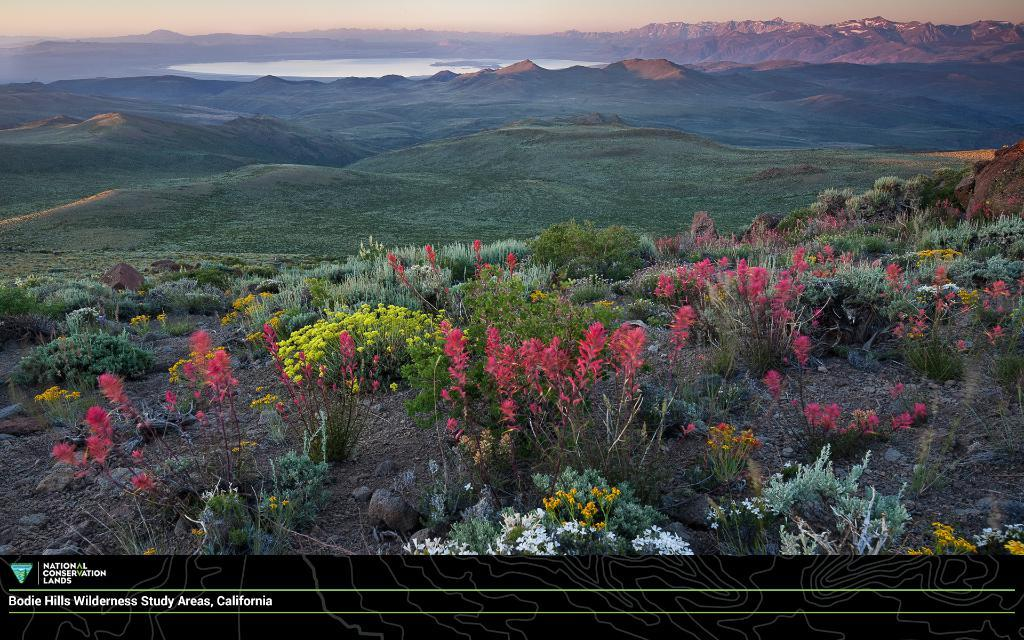What type of vegetation is at the bottom of the image? There are flower plants at the bottom of the image. What natural landmarks can be seen in the background of the image? There are mountains in the background of the image. What type of ground cover is visible in the image? There is grass visible in the image. What body of water can be seen in the image? There is water visible in the image. What type of ink is used to draw the ghost in the image? There is no ghost present in the image, so there is no ink used to draw it. What type of sun can be seen in the image? The provided facts do not mention a sun in the image, so we cannot determine its type. 